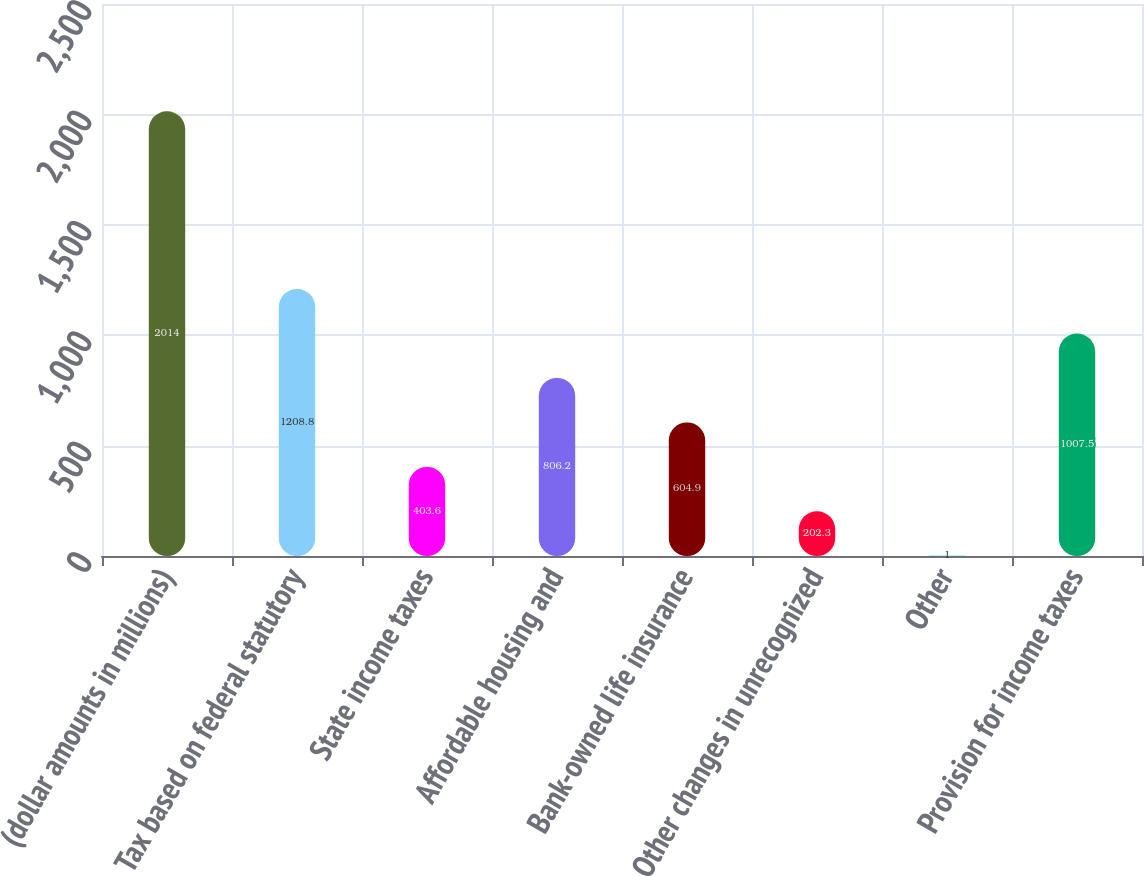Convert chart. <chart><loc_0><loc_0><loc_500><loc_500><bar_chart><fcel>(dollar amounts in millions)<fcel>Tax based on federal statutory<fcel>State income taxes<fcel>Affordable housing and<fcel>Bank-owned life insurance<fcel>Other changes in unrecognized<fcel>Other<fcel>Provision for income taxes<nl><fcel>2014<fcel>1208.8<fcel>403.6<fcel>806.2<fcel>604.9<fcel>202.3<fcel>1<fcel>1007.5<nl></chart> 